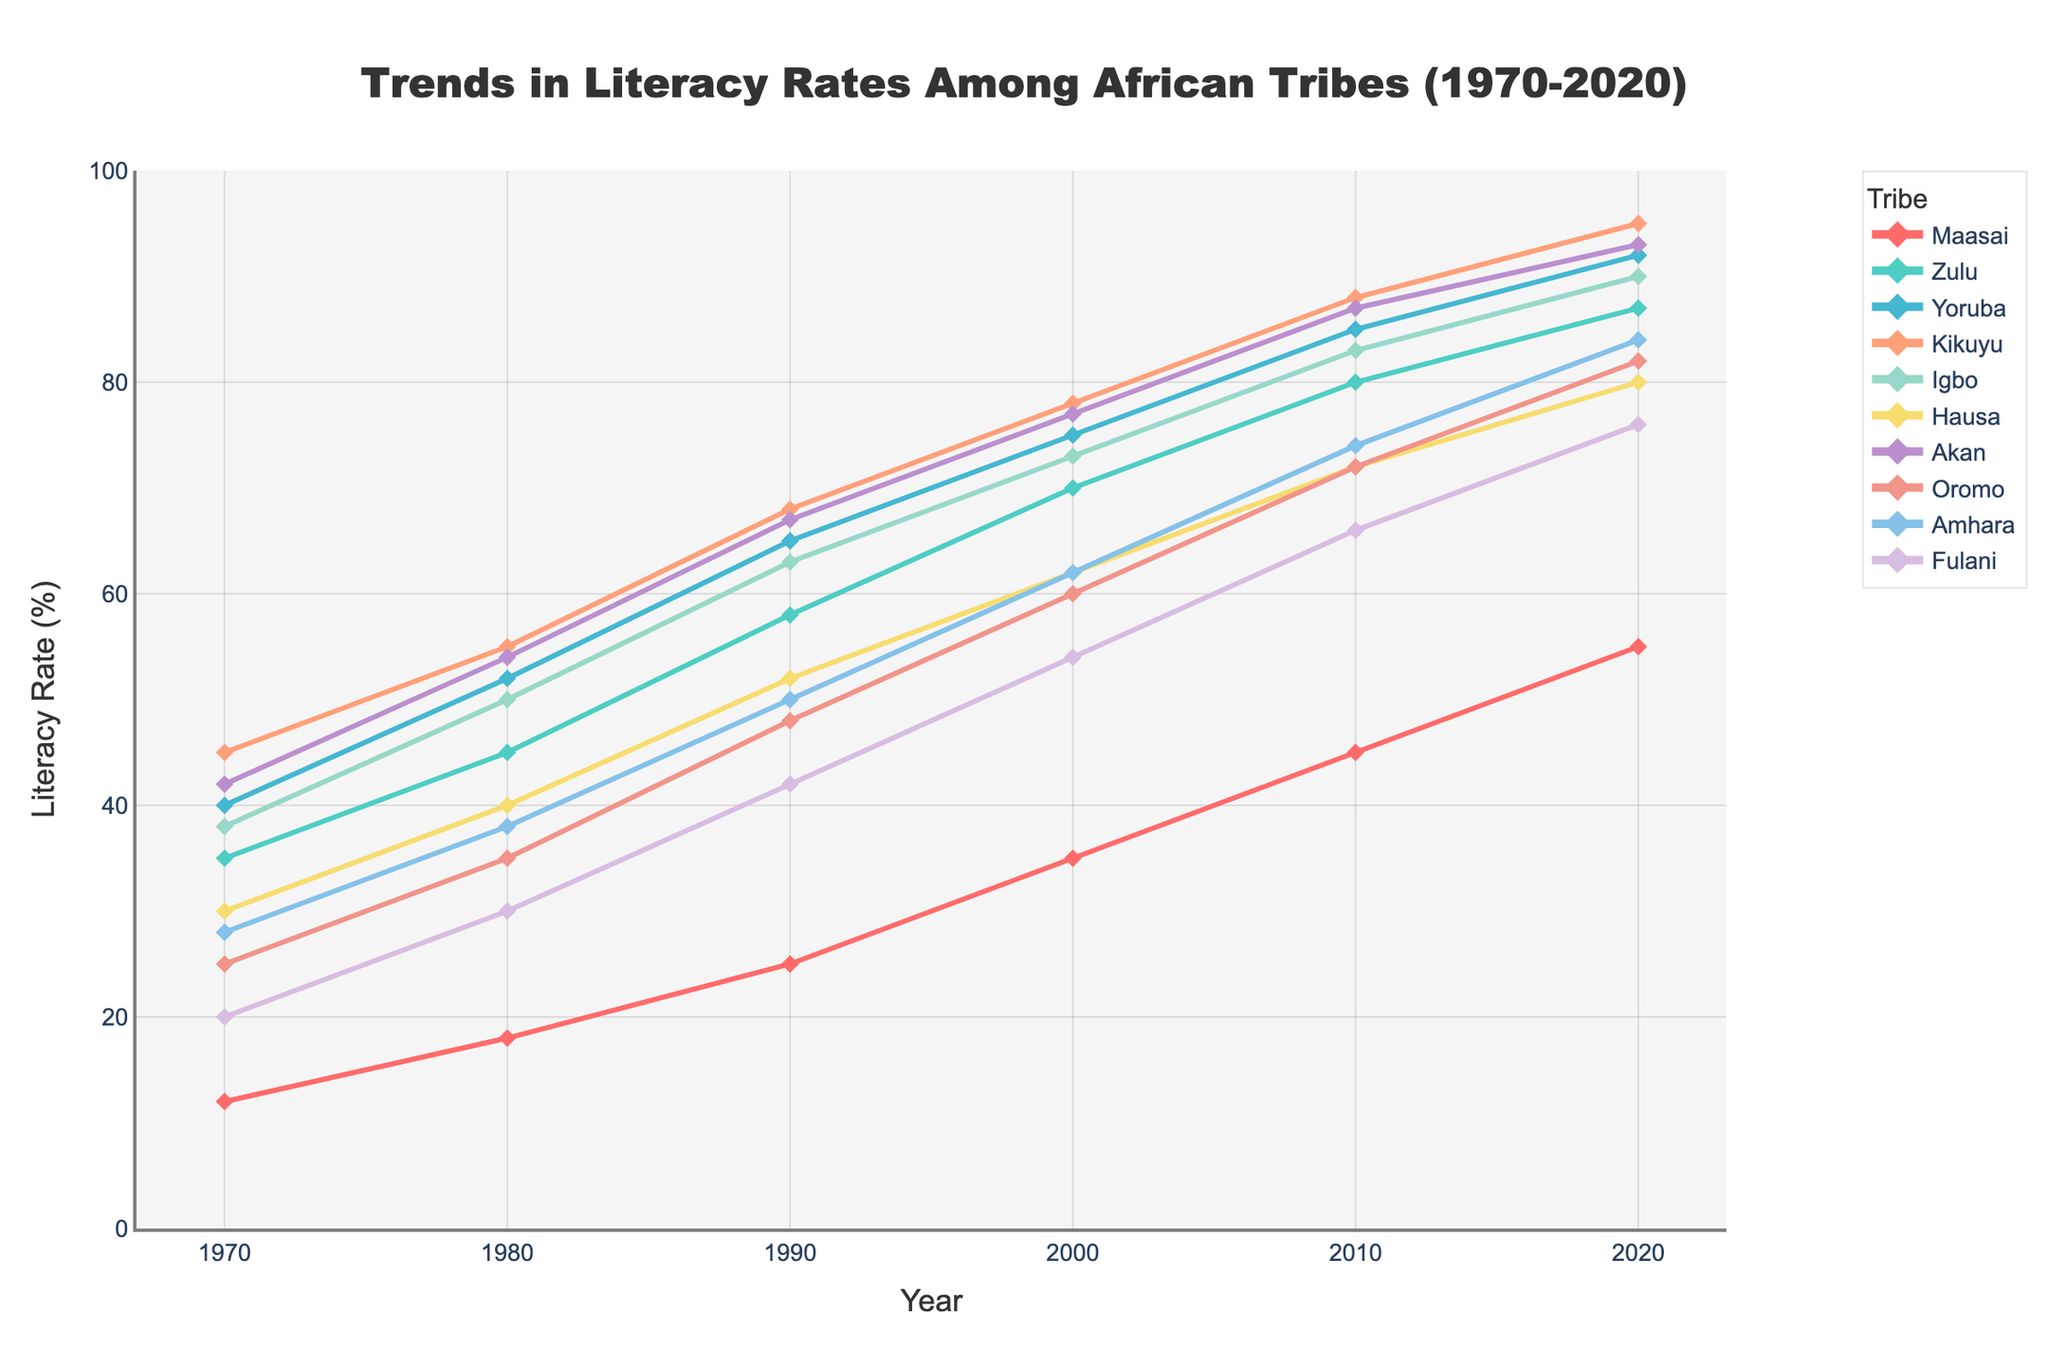Which tribe had the highest literacy rate in 2020? By looking at the end of the line chart for the year 2020, we observe that the Kikuyu tribe has the highest literacy rate.
Answer: Kikuyu Which two tribes had the greatest increase in literacy rate from 1970 to 2020? By comparing the difference in literacy rates for each tribe from 1970 to 2020, Kikuyu increased from 45 to 95 (a change of 50), and Yoruba increased from 40 to 92 (a change of 52).
Answer: Yoruba, Kikuyu Which tribes had nearly identical literacy rates in 1990? By comparing the values for 1990, the tribes Zulu and Yoruba had almost identical literacy rates (58 and 65, respectively).
Answer: Zulu, Yoruba Are there any tribes that show a continuous increase in literacy rate over the period of 1970 to 2020? Observing the trends of all the lines, we see that all the tribes show a continuous increase in literacy rate from 1970 to 2020.
Answer: Yes Which tribe had the lowest literacy rate in 1970? By checking the beginning of the line chart for 1970, we observe that the Maasai tribe had the lowest literacy rate.
Answer: Maasai What is the range of literacy rates for the Hausa tribe from 1970 to 2020? To find the range, we subtract the lowest value (30 in 1970) from the highest value (80 in 2020) which gives us 50.
Answer: 50 Compare the literacy rates of the Amhara and Oromo tribes in 2010. Which tribe had a higher rate? Checking the literacy rates for 2010, the Amhara tribe had a literacy rate of 74, while the Oromo tribe had a literacy rate of 72.
Answer: Amhara What is the average literacy rate of the Zulu tribe from 1970 to 2020? Summing the Zulu literacy rates for each decade (35, 45, 58, 70, 80, 87) and dividing by the number of data points (6), the average is (35+45+58+70+80+87)/6 = 62.5.
Answer: 62.5 Which tribe had a literacy rate closest to 50% in 2000? By referring to the values for the year 2000, the Fulani tribe had a literacy rate of 54%, which is the closest to 50%.
Answer: Fulani Did any tribe reach or exceed a 90% literacy rate by 2020? If so, which? By checking the values for 2020, the tribes Yoruba (92), Kikuyu (95), Akan (93), and Igbo (90) have reached or exceeded 90%.
Answer: Yoruba, Kikuyu, Akan, Igbo 